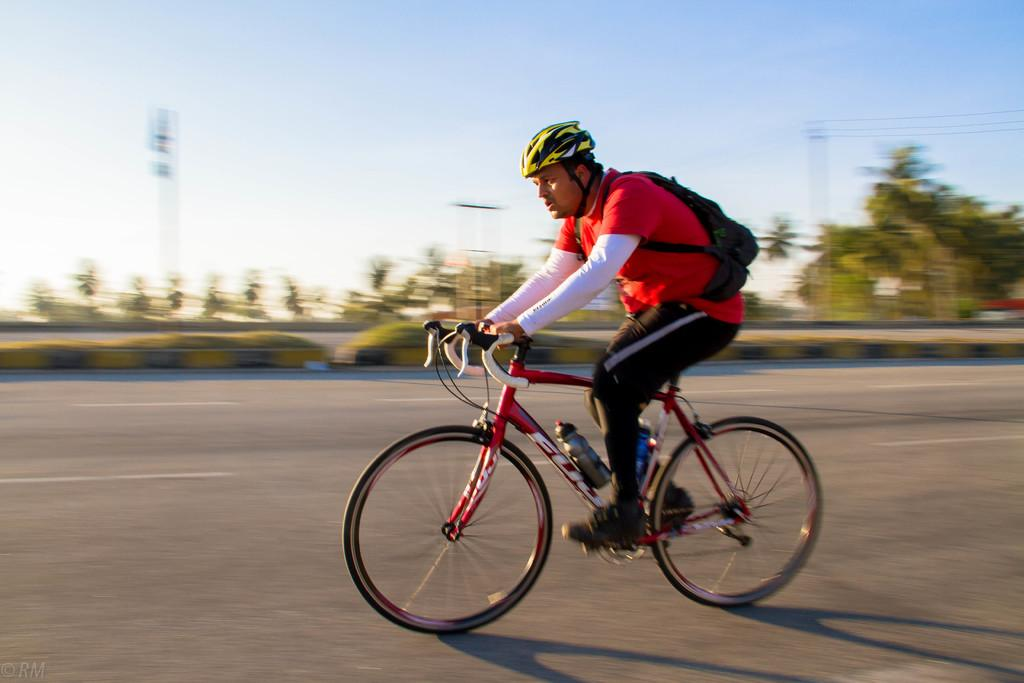What is the person in the image doing? The person is riding a bicycle in the image. What safety precaution is the person taking while riding the bicycle? The person is wearing a helmet. What is the person carrying while riding the bicycle? The person is carrying a bag. Where is the bicycle located in the image? The bicycle is on the road. What can be seen in the background of the image? There are trees, a pole, and the sky visible in the background of the image. What substance is the person kicking in the image? There is no substance being kicked in the image; the person is riding a bicycle. 